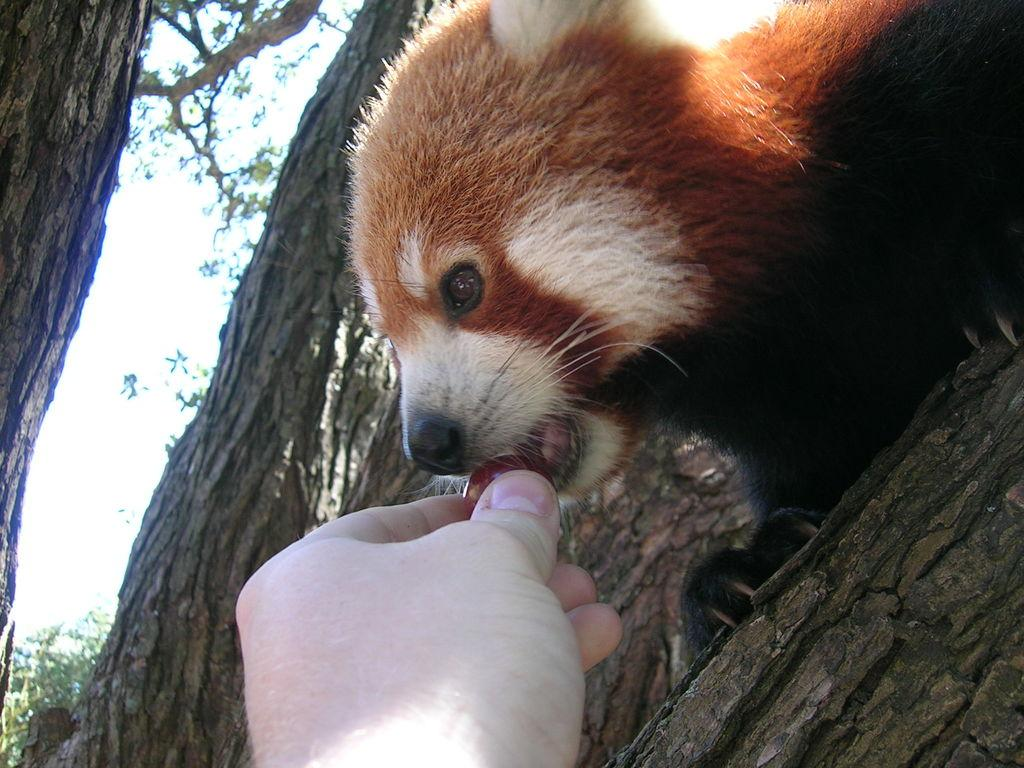What body part is visible in the image? There is a person's hand in the image. What is the animal doing in the image? The animal is on a tree in the image. What type of vegetation can be seen in the image? There are trees visible in the image. What is visible at the top of the image? The sky is visible at the top of the image. How many snakes are slithering on the ground in the image? There are no snakes visible in the image; it features a person's hand and an animal on a tree. What time of day is depicted in the image? The time of day cannot be determined from the image, as there are no specific indicators of time. 